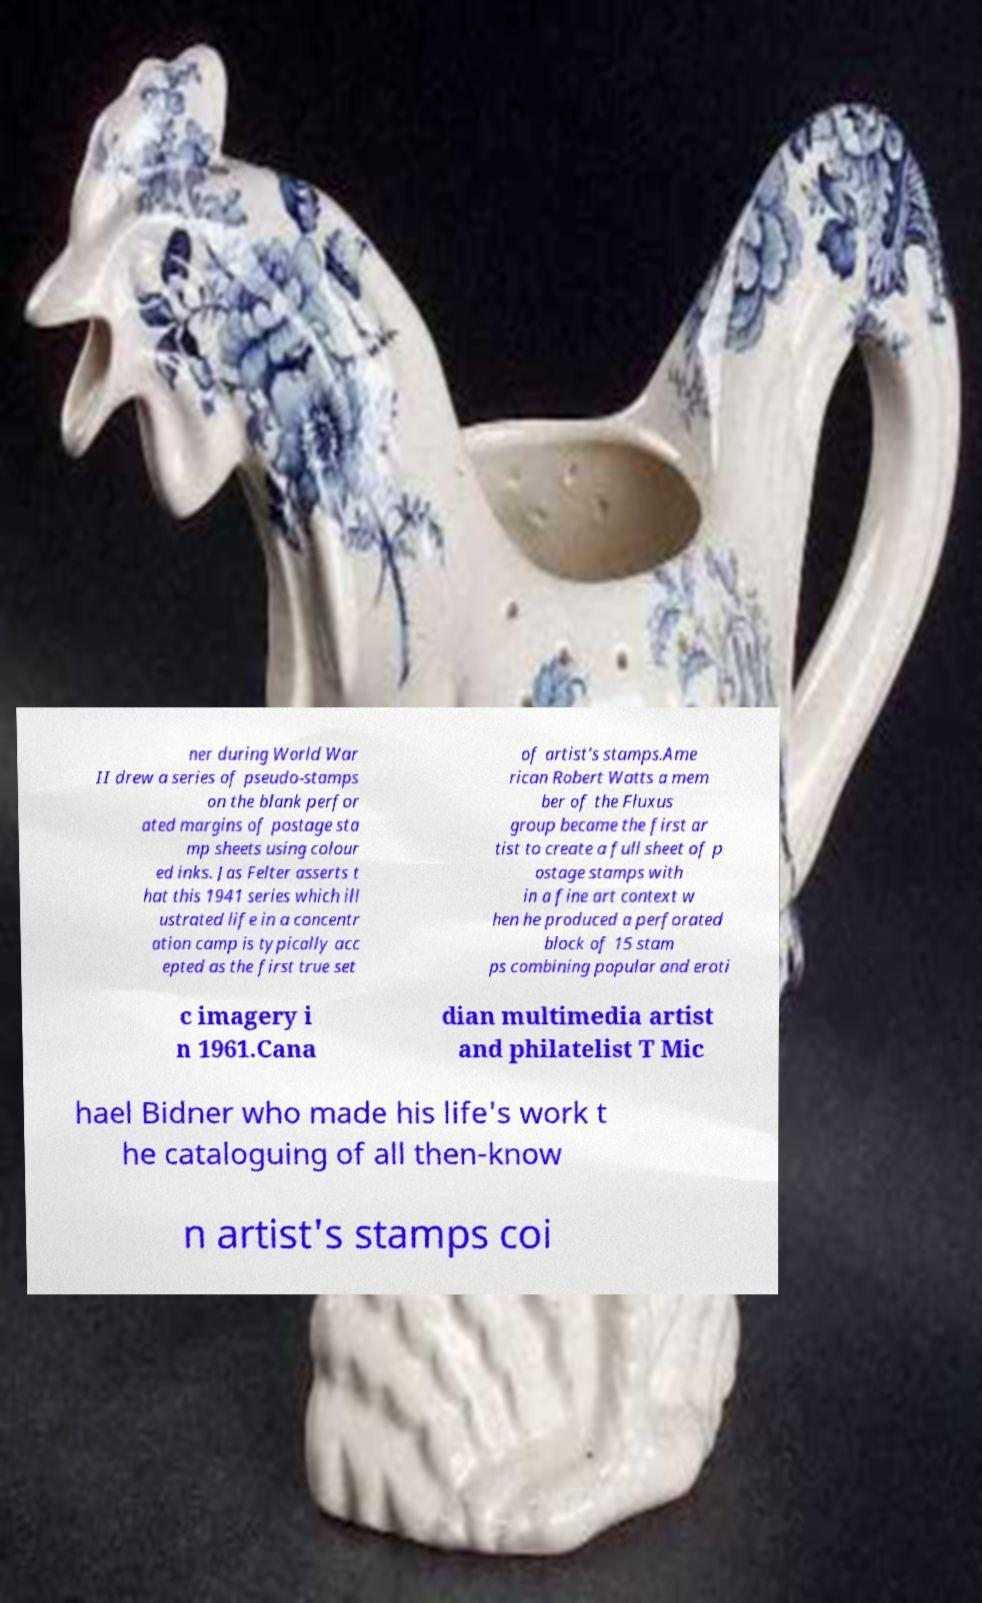For documentation purposes, I need the text within this image transcribed. Could you provide that? ner during World War II drew a series of pseudo-stamps on the blank perfor ated margins of postage sta mp sheets using colour ed inks. Jas Felter asserts t hat this 1941 series which ill ustrated life in a concentr ation camp is typically acc epted as the first true set of artist's stamps.Ame rican Robert Watts a mem ber of the Fluxus group became the first ar tist to create a full sheet of p ostage stamps with in a fine art context w hen he produced a perforated block of 15 stam ps combining popular and eroti c imagery i n 1961.Cana dian multimedia artist and philatelist T Mic hael Bidner who made his life's work t he cataloguing of all then-know n artist's stamps coi 